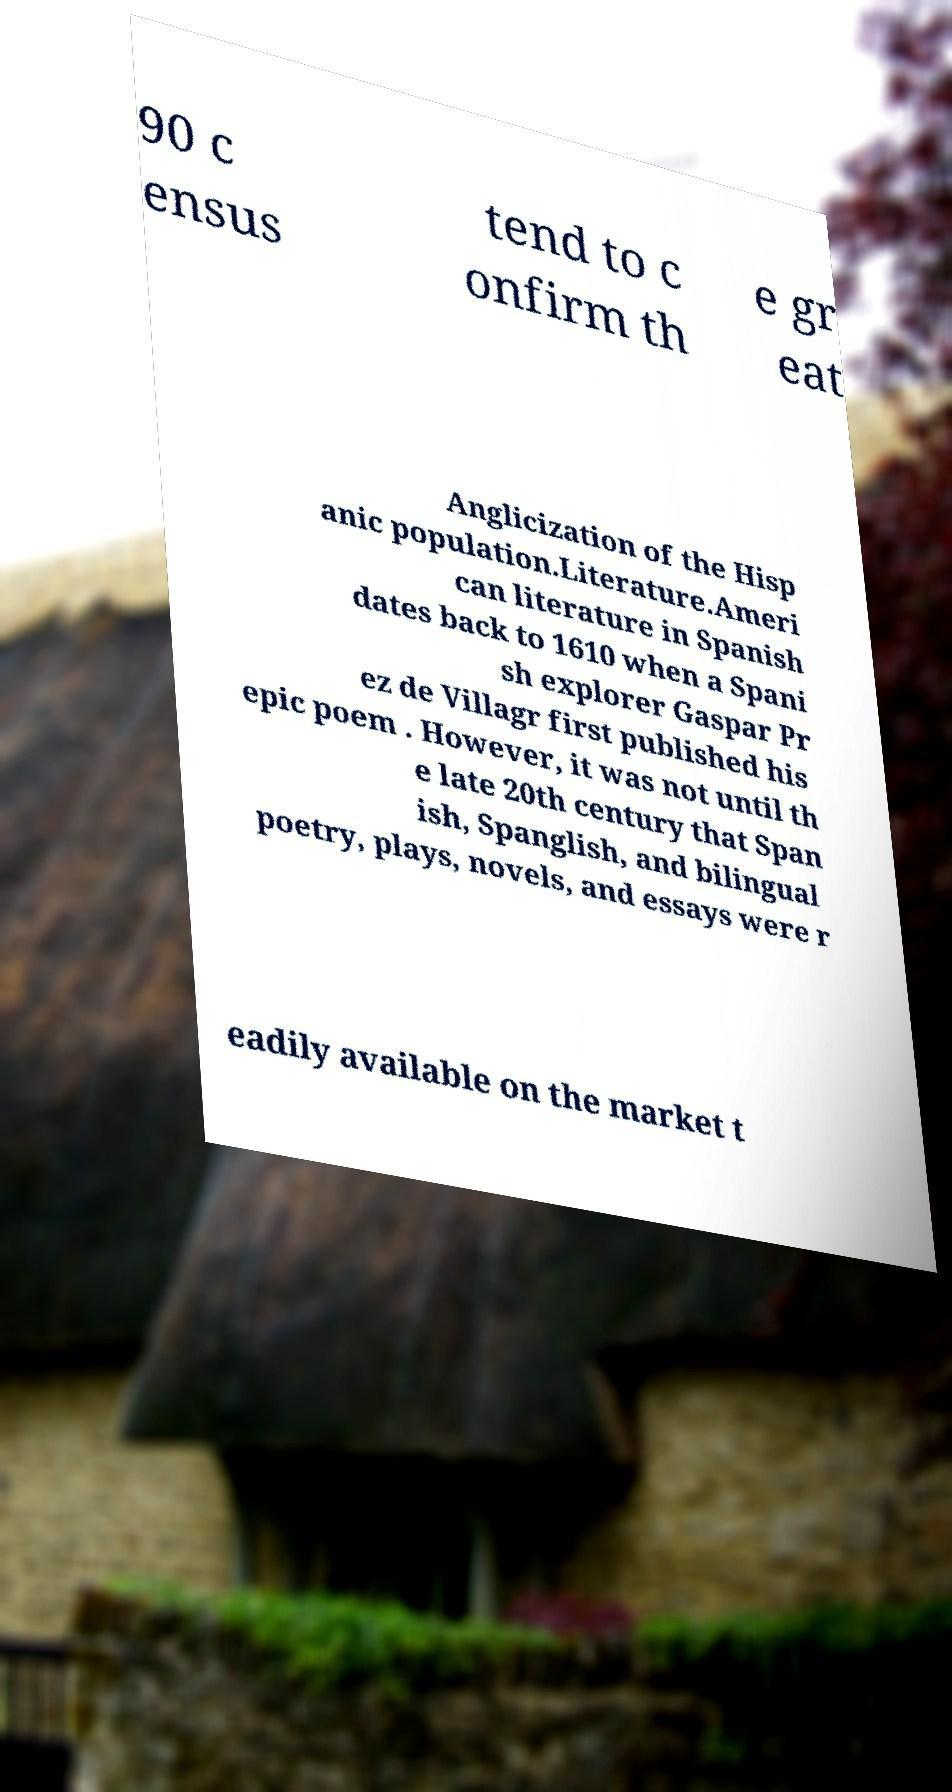Can you read and provide the text displayed in the image?This photo seems to have some interesting text. Can you extract and type it out for me? 90 c ensus tend to c onfirm th e gr eat Anglicization of the Hisp anic population.Literature.Ameri can literature in Spanish dates back to 1610 when a Spani sh explorer Gaspar Pr ez de Villagr first published his epic poem . However, it was not until th e late 20th century that Span ish, Spanglish, and bilingual poetry, plays, novels, and essays were r eadily available on the market t 